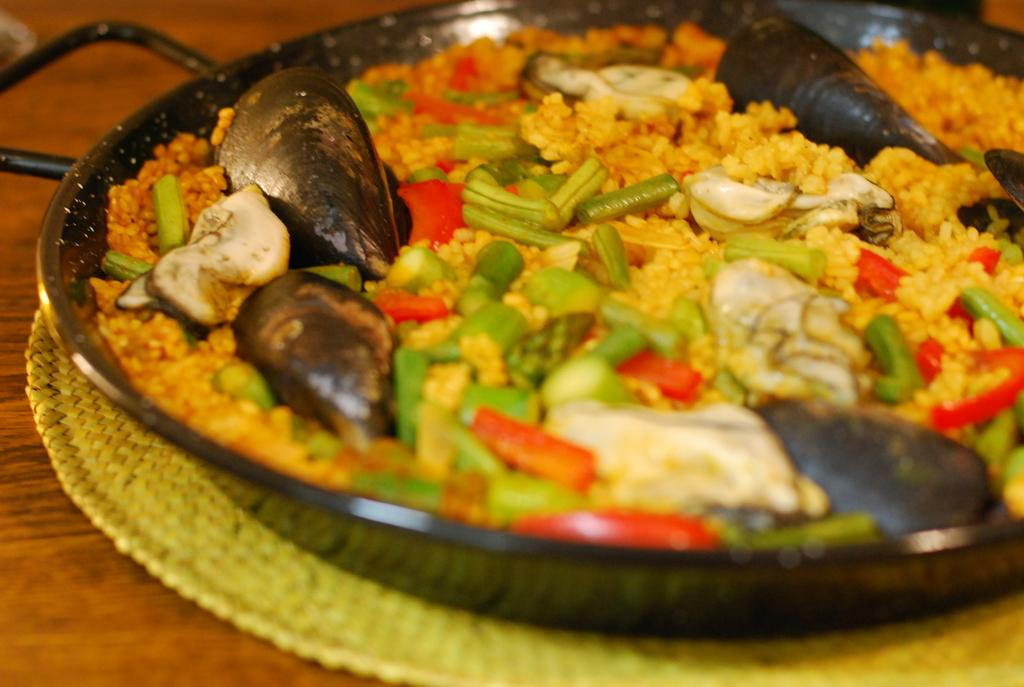What is the main object in the image? There is a pan in the image. Where is the pan located? The pan is on a mat. What is the surface beneath the mat? The mat is on a wooden surface. What type of food is being prepared in the pan? There is a food item with vegetables in the pan. What specific ingredient can be seen in the food item? There are shells in the food item. Are there any other ingredients visible in the food item? Yes, there are other unspecified items in the food item. What type of flower is being used as a secretary in the image? There is no flower or secretary present in the image; it features a pan with a food item on a wooden surface. 